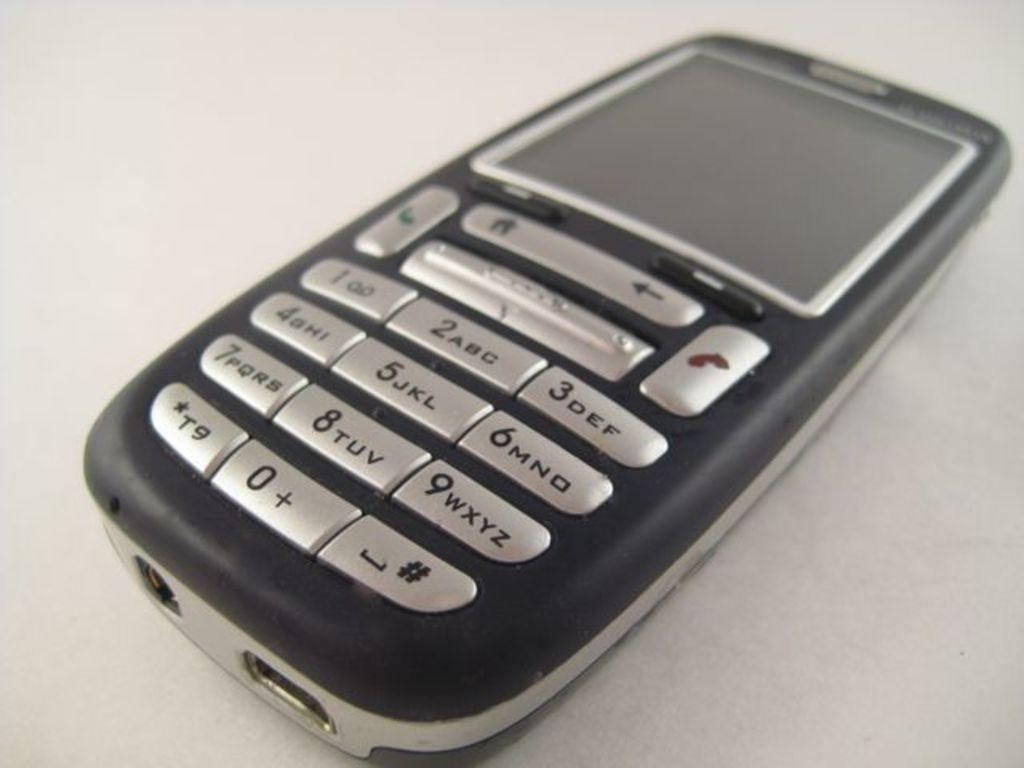<image>
Give a short and clear explanation of the subsequent image. A small phone has silver buttons and the 9 key says WXYZ. 